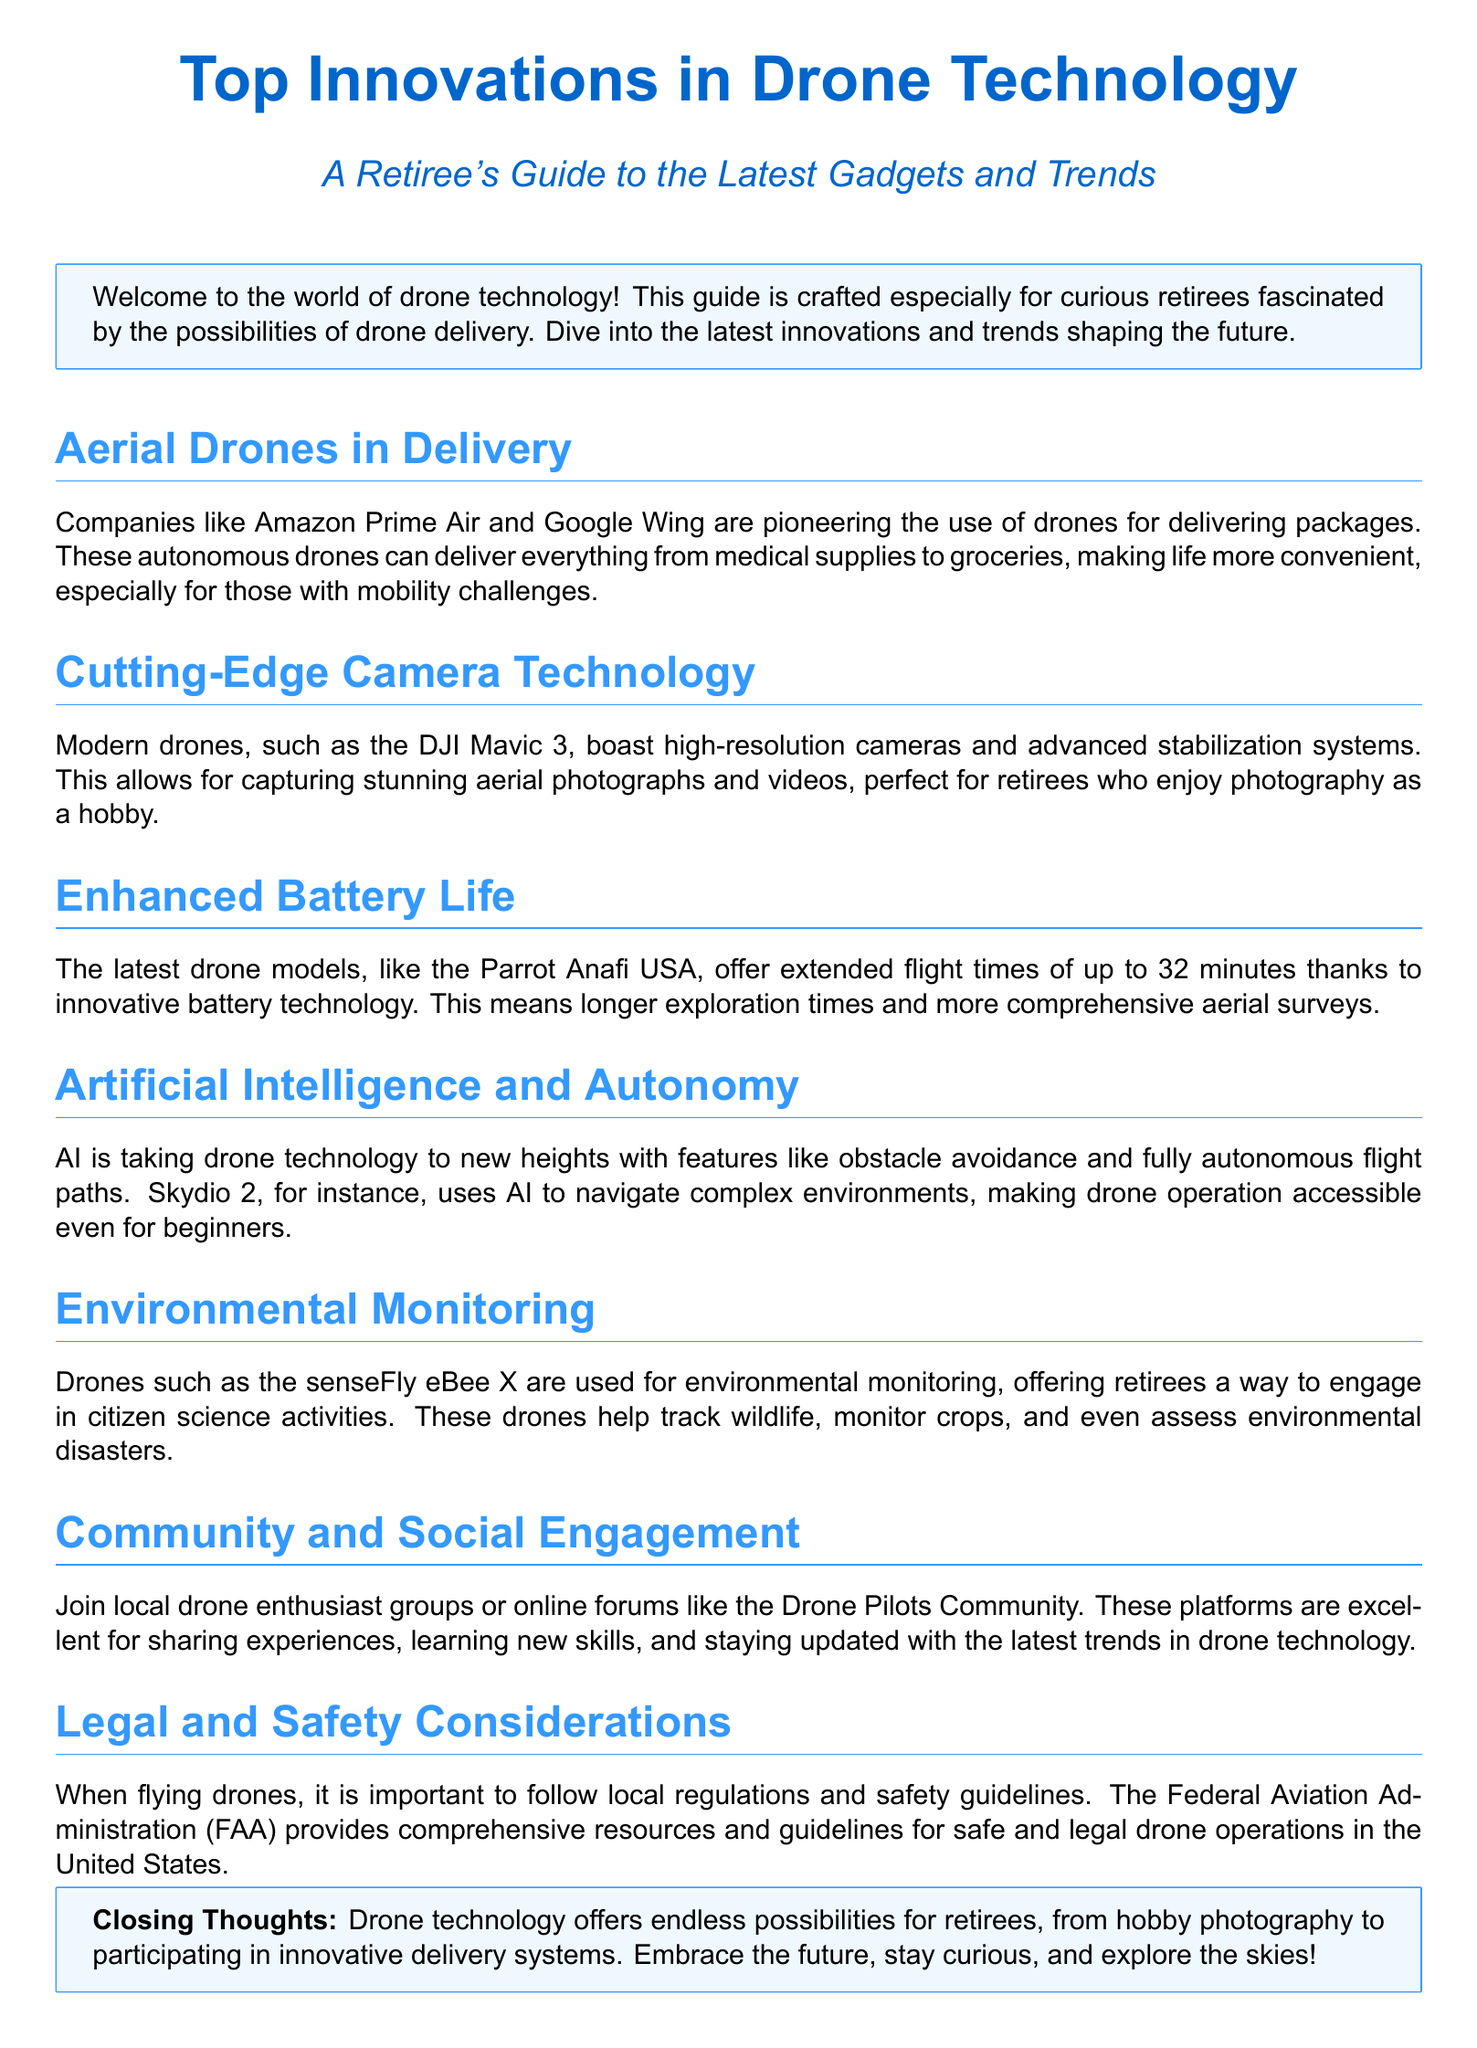What companies are mentioned for drone delivery? The document states that companies like Amazon Prime Air and Google Wing are pioneers in drone delivery.
Answer: Amazon Prime Air and Google Wing What type of drone is highlighted for its camera technology? The document mentions the DJI Mavic 3 for its high-resolution cameras and advanced stabilization systems.
Answer: DJI Mavic 3 How long can the latest drone models fly according to the document? The document states that the latest drone models can offer extended flight times of up to 32 minutes.
Answer: 32 minutes What feature does Skydio 2 provide for drone navigation? The document highlights that Skydio 2 uses AI for obstacle avoidance and fully autonomous flight paths.
Answer: AI for obstacle avoidance What is a suggested activity for retirees according to the document? The document suggests engaging in citizen science activities using drones for environmental monitoring.
Answer: Citizen science activities What does the document advise regarding drone operations? The document emphasizes following local regulations and safety guidelines for safe and legal drone operations.
Answer: Follow local regulations What type of groups can retirees join for drone engagement? The document mentions local drone enthusiast groups or online forums like the Drone Pilots Community.
Answer: Drone enthusiast groups What technology is being utilized for environmental monitoring? The document states that drones such as the senseFly eBee X are used for environmental monitoring.
Answer: senseFly eBee X 